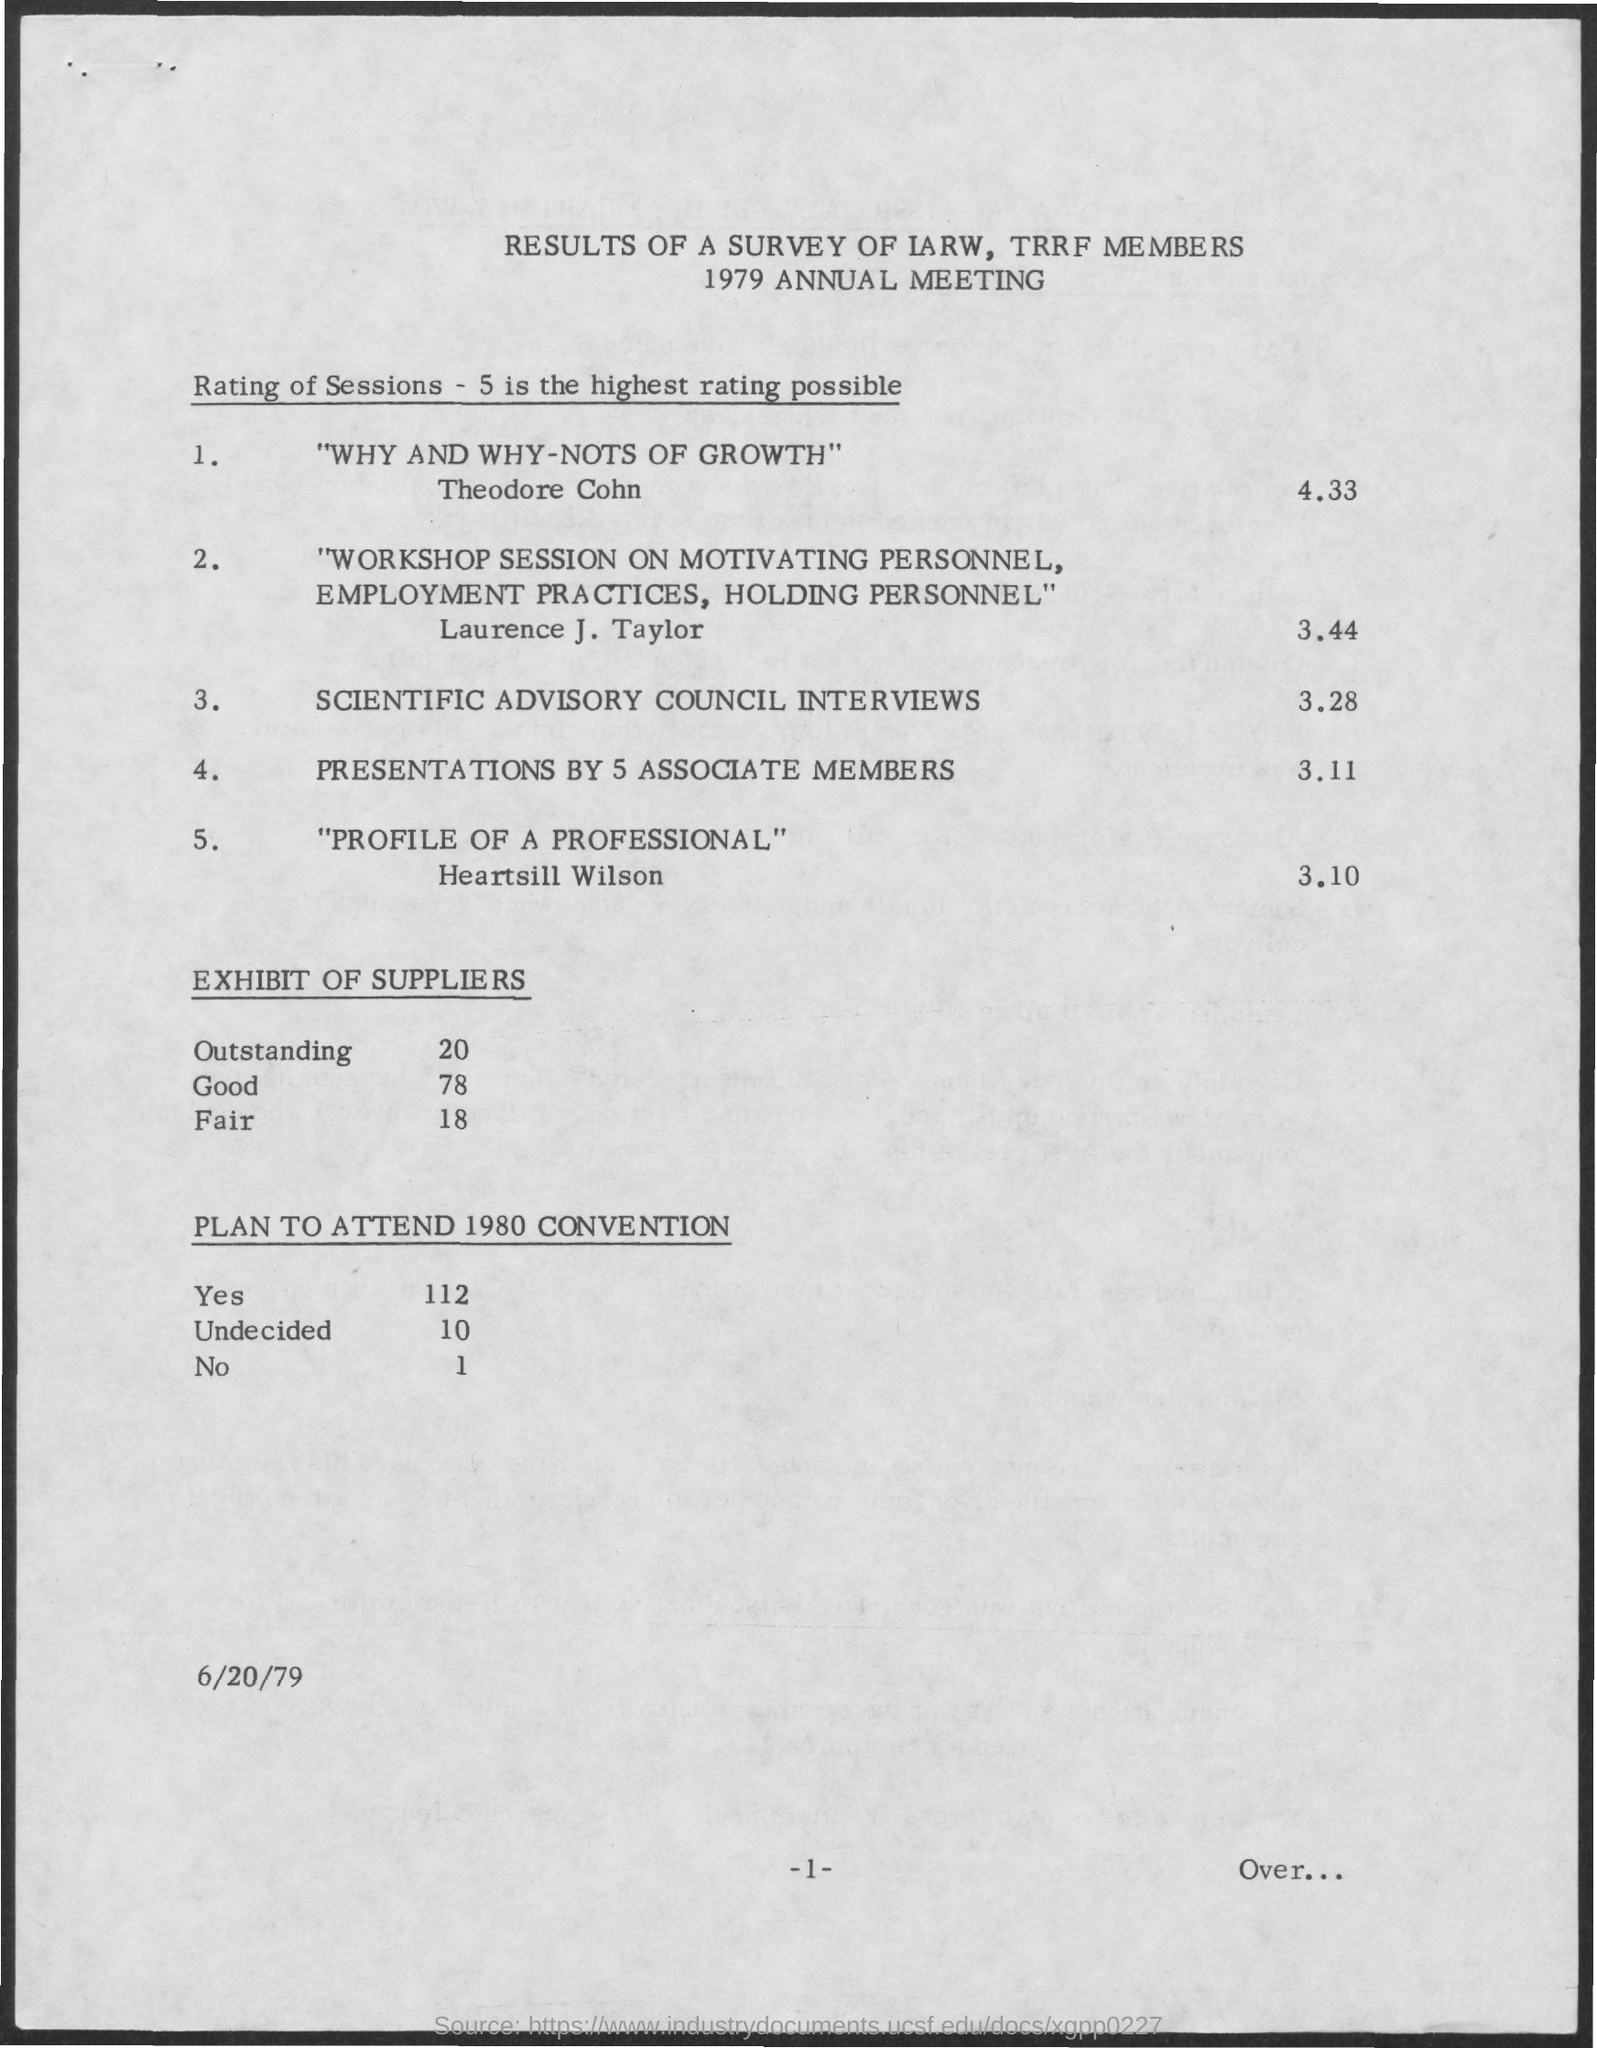What is the first title in the document?
Your answer should be compact. Results of a survey of iarw, trrf members. What is the date mentioned in the document?
Your answer should be compact. 6/20/79. What is the Page Number?
Provide a short and direct response. -1-. How many people plan to attend the 1980 convention?
Keep it short and to the point. 112. How many people plan not to attend the 1980 convention?
Offer a terse response. 1. How many people still not yet decided?
Your response must be concise. 10. 